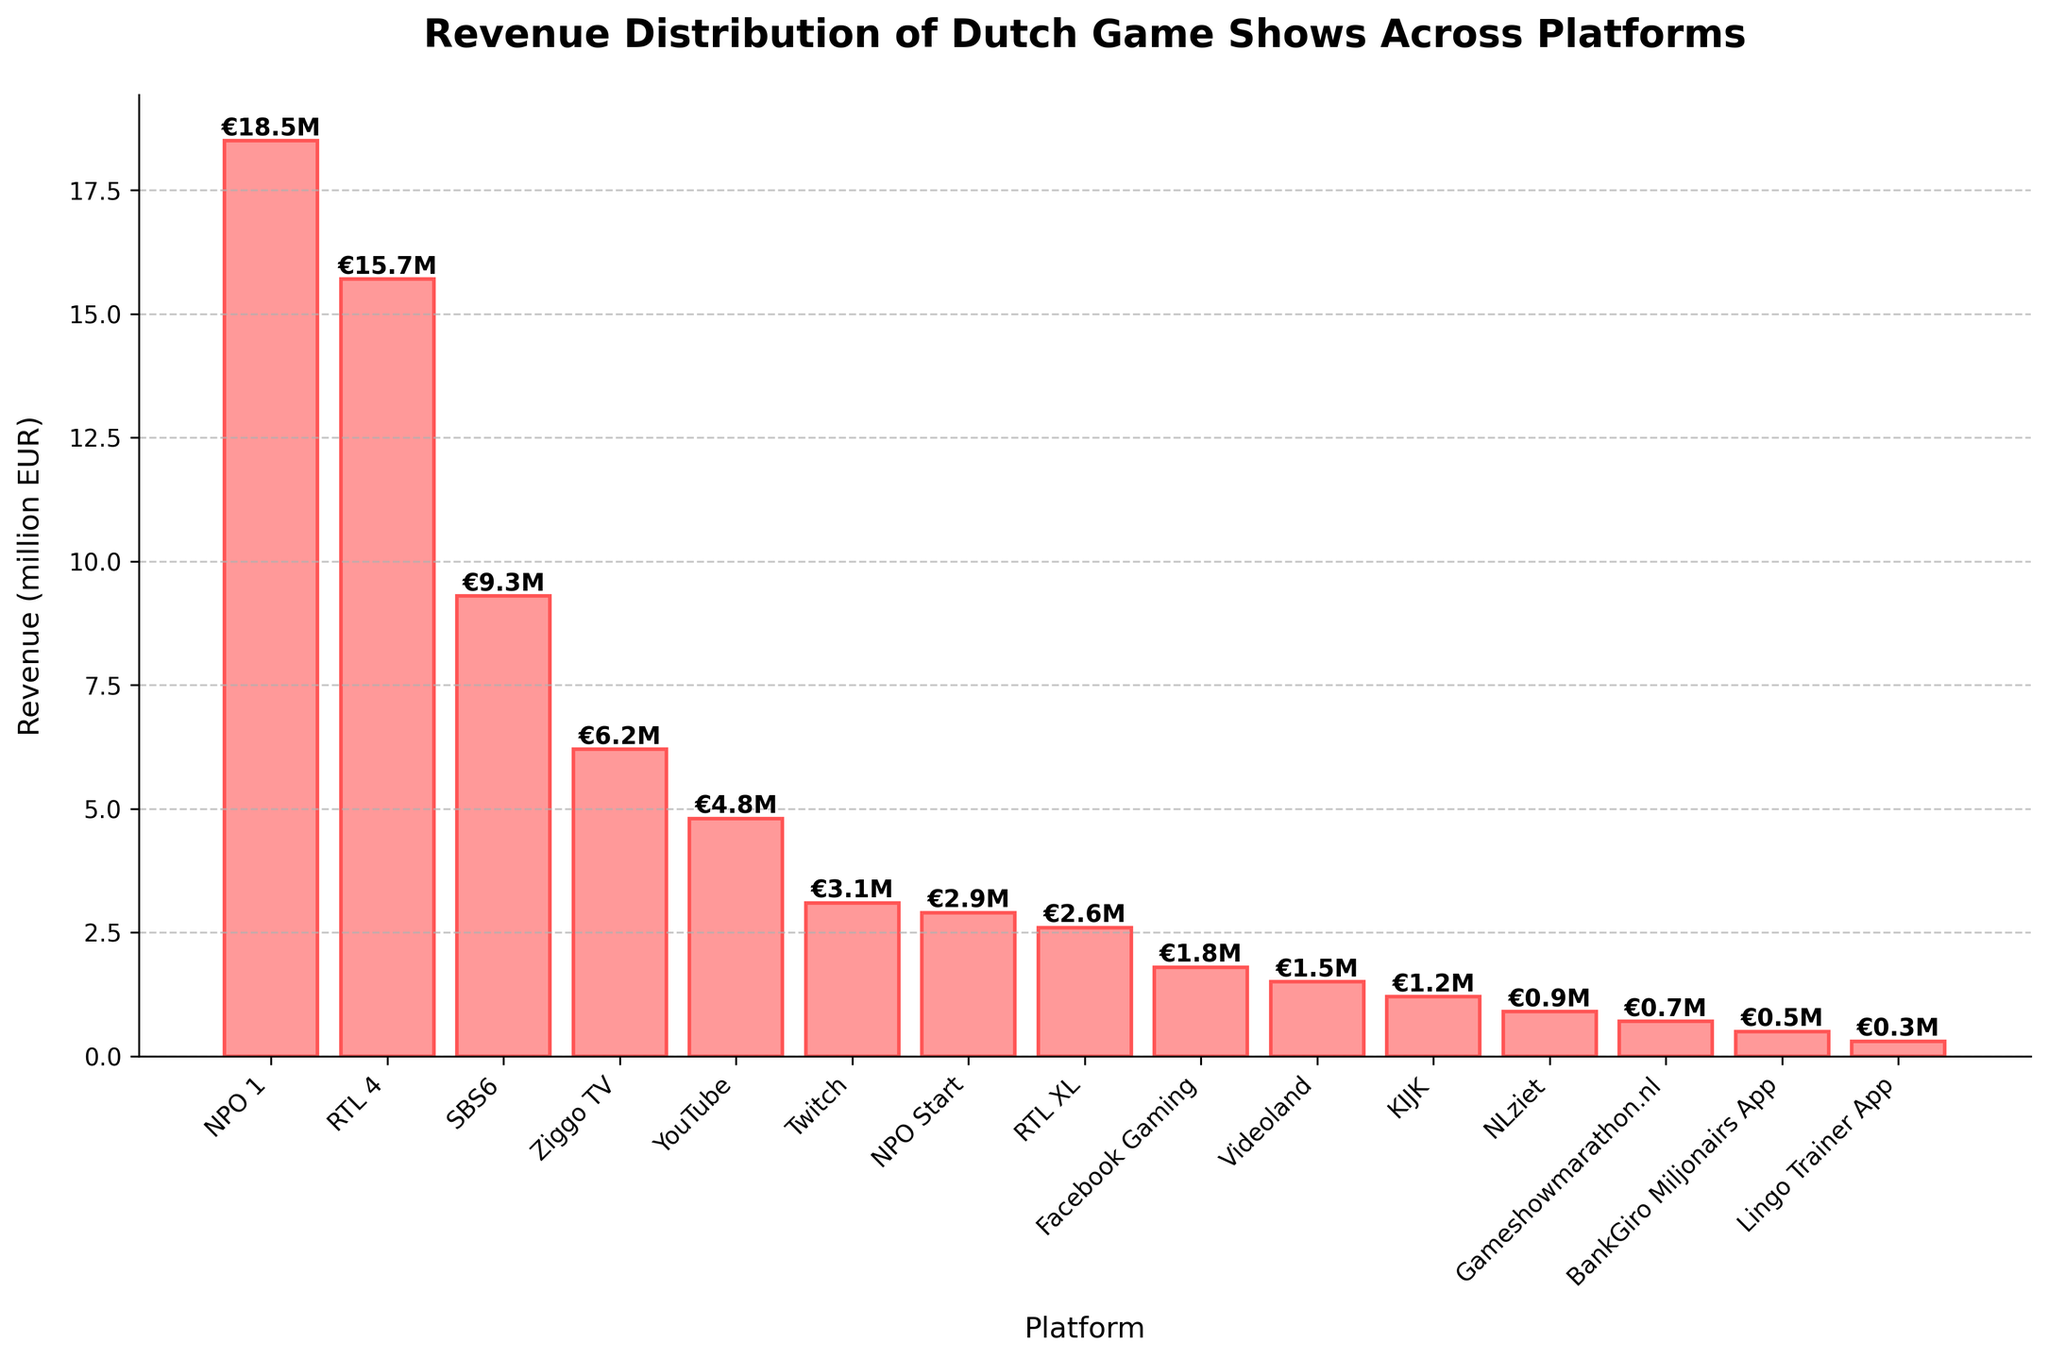What platform has the highest revenue for Dutch game shows? By visual inspection of the tallest bar on the chart, it is easy to identify the platform with the highest revenue.
Answer: NPO 1 What is the total revenue generated by RTL 4 and SBS6 combined? The revenue of RTL 4 is €15.7 million and the revenue of SBS6 is €9.3 million. Adding these together: €15.7 million + €9.3 million = €25.0 million.
Answer: €25.0 million Which online platform has the highest revenue? The online platforms listed are YouTube, Twitch, NPO Start, RTL XL, Facebook Gaming, Videoland, KIJK, NLziet, Gameshowmarathon.nl, BankGiro Miljonairs App, and Lingo Trainer App. Among these, YouTube has the highest revenue at €4.8 million.
Answer: YouTube How much more revenue does NPO 1 generate compared to Ziggo TV? Subtract the revenue of Ziggo TV from that of NPO 1. NPO 1 has €18.5 million and Ziggo TV has €6.2 million. The difference is €18.5 million - €6.2 million = €12.3 million.
Answer: €12.3 million What is the average revenue of the mobile platforms listed? The mobile platforms listed are the BankGiro Miljonairs App (€0.5 million) and the Lingo Trainer App (€0.3 million). The average revenue is calculated as (0.5 + 0.3) / 2 = 0.4.
Answer: €0.4 million Which platform generates the least revenue and how much is it? By identifying the shortest bar on the bar chart, the platform with the least revenue is revealed.
Answer: Lingo Trainer App, €0.3 million Are there more television or online platforms generating revenue for Dutch game shows? Count the number of television platforms (NPO 1, RTL 4, SBS6, Ziggo TV) and online platforms (YouTube, Twitch, NPO Start, RTL XL, Facebook Gaming, Videoland, KIJK, NLziet, Gameshowmarathon.nl). We have 4 television platforms and 9 online platforms.
Answer: Online platforms What is the combined revenue of the top three platforms? The top three platforms in terms of revenue are NPO 1 (€18.5 million), RTL 4 (€15.7 million), and SBS6 (€9.3 million). Summing these revenues gives €18.5 million + €15.7 million + €9.3 million = €43.5 million.
Answer: €43.5 million Which platform ranks fourth in terms of revenue? By visually ranking the bar heights, the fourth highest revenue is generated by Ziggo TV at €6.2 million.
Answer: Ziggo TV What is the median revenue of the platforms listed? To find the median, first list the platforms' revenues in ascending order: 0.3, 0.5, 0.7, 0.9, 1.2, 1.5, 1.8, 2.6, 2.9, 3.1, 4.8, 6.2, 9.3, 15.7, 18.5. There are 15 platforms, so the median value is the 8th value: €2.6 million.
Answer: €2.6 million 